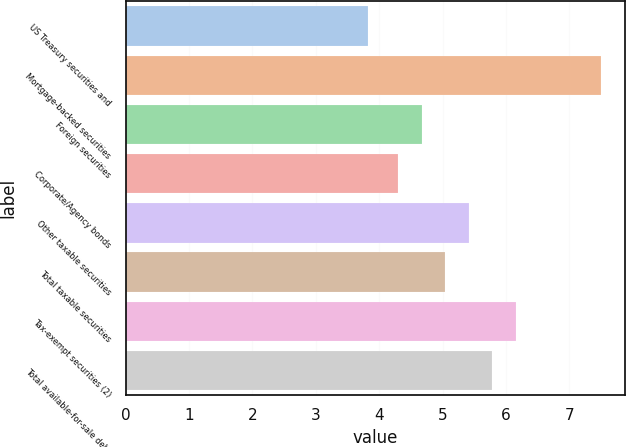Convert chart. <chart><loc_0><loc_0><loc_500><loc_500><bar_chart><fcel>US Treasury securities and<fcel>Mortgage-backed securities<fcel>Foreign securities<fcel>Corporate/Agency bonds<fcel>Other taxable securities<fcel>Total taxable securities<fcel>Tax-exempt securities (2)<fcel>Total available-for-sale debt<nl><fcel>3.82<fcel>7.5<fcel>4.67<fcel>4.3<fcel>5.41<fcel>5.04<fcel>6.15<fcel>5.78<nl></chart> 